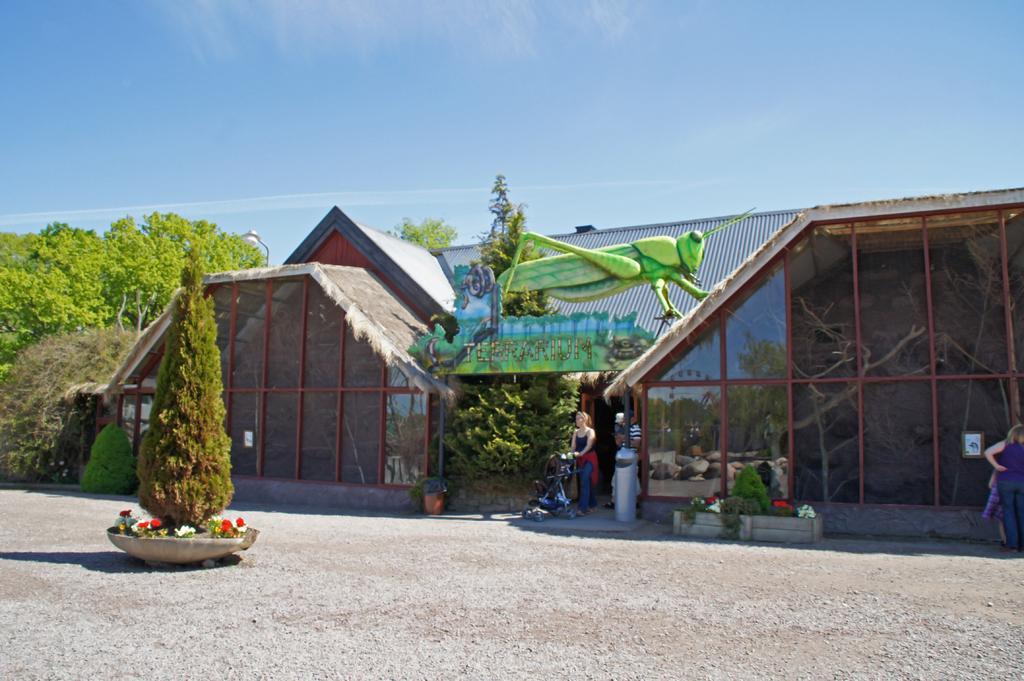Can you describe this image briefly? This picture is taken from outside of the building. In this image, on the right side, we can see a woman standing on the land. In the middle of the image, we can see two people man and woman and woman is holding a vehicle in her hand. On the left side, we can see a flower pot with some flowers and a plant, trees. In the background, we can see an insect which is in green color, plants, trees, building, glass window. At the top, we can see a sky, at the bottom, we can see a road. 